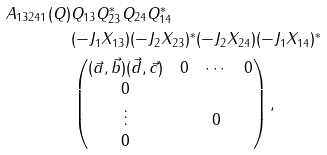Convert formula to latex. <formula><loc_0><loc_0><loc_500><loc_500>A _ { 1 3 2 4 1 } ( Q ) & Q _ { 1 3 } Q _ { 2 3 } ^ { * } Q _ { 2 4 } Q _ { 1 4 } ^ { * } \\ & ( - J _ { 1 } X _ { 1 3 } ) ( - J _ { 2 } X _ { 2 3 } ) ^ { * } ( - J _ { 2 } X _ { 2 4 } ) ( - J _ { 1 } X _ { 1 4 } ) ^ { * } \\ & \begin{pmatrix} ( \vec { a } , \vec { b } ) ( \vec { d } , \vec { c } ) & 0 & \cdots & 0 \\ 0 & & & \\ \vdots & & $ 0 $ & \\ 0 & & & \end{pmatrix} ,</formula> 